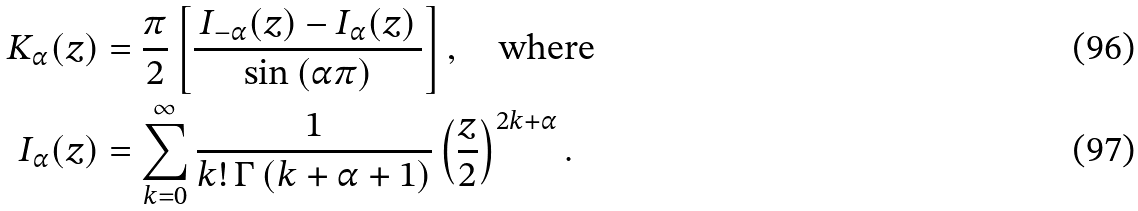<formula> <loc_0><loc_0><loc_500><loc_500>K _ { \alpha } ( z ) & = \frac { \pi } { 2 } \left [ \frac { \, I _ { - \alpha } ( z ) - I _ { \alpha } ( z ) \, } { \sin \left ( \alpha \pi \right ) } \right ] , \quad \text {where} \\ I _ { \alpha } ( z ) & = \sum _ { k = 0 } ^ { \infty } \frac { 1 } { k ! \, \Gamma \left ( k + \alpha + 1 \right ) } \left ( \frac { z } { 2 } \right ) ^ { 2 k + \alpha } .</formula> 